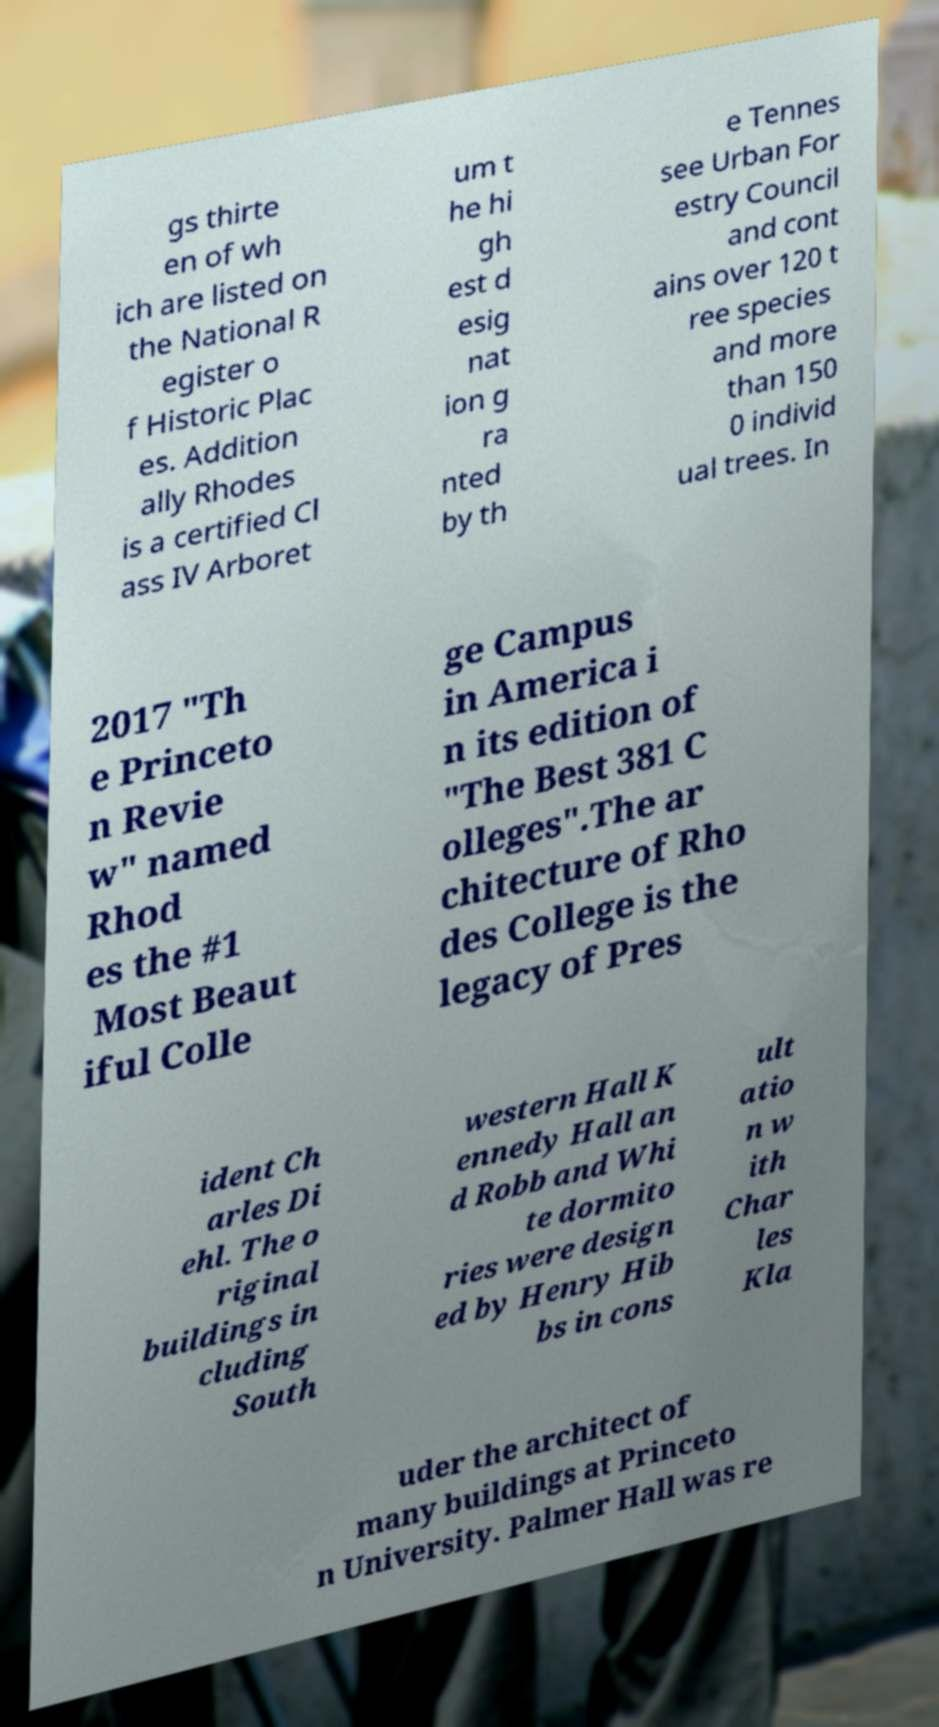Could you assist in decoding the text presented in this image and type it out clearly? gs thirte en of wh ich are listed on the National R egister o f Historic Plac es. Addition ally Rhodes is a certified Cl ass IV Arboret um t he hi gh est d esig nat ion g ra nted by th e Tennes see Urban For estry Council and cont ains over 120 t ree species and more than 150 0 individ ual trees. In 2017 "Th e Princeto n Revie w" named Rhod es the #1 Most Beaut iful Colle ge Campus in America i n its edition of "The Best 381 C olleges".The ar chitecture of Rho des College is the legacy of Pres ident Ch arles Di ehl. The o riginal buildings in cluding South western Hall K ennedy Hall an d Robb and Whi te dormito ries were design ed by Henry Hib bs in cons ult atio n w ith Char les Kla uder the architect of many buildings at Princeto n University. Palmer Hall was re 